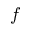Convert formula to latex. <formula><loc_0><loc_0><loc_500><loc_500>f</formula> 